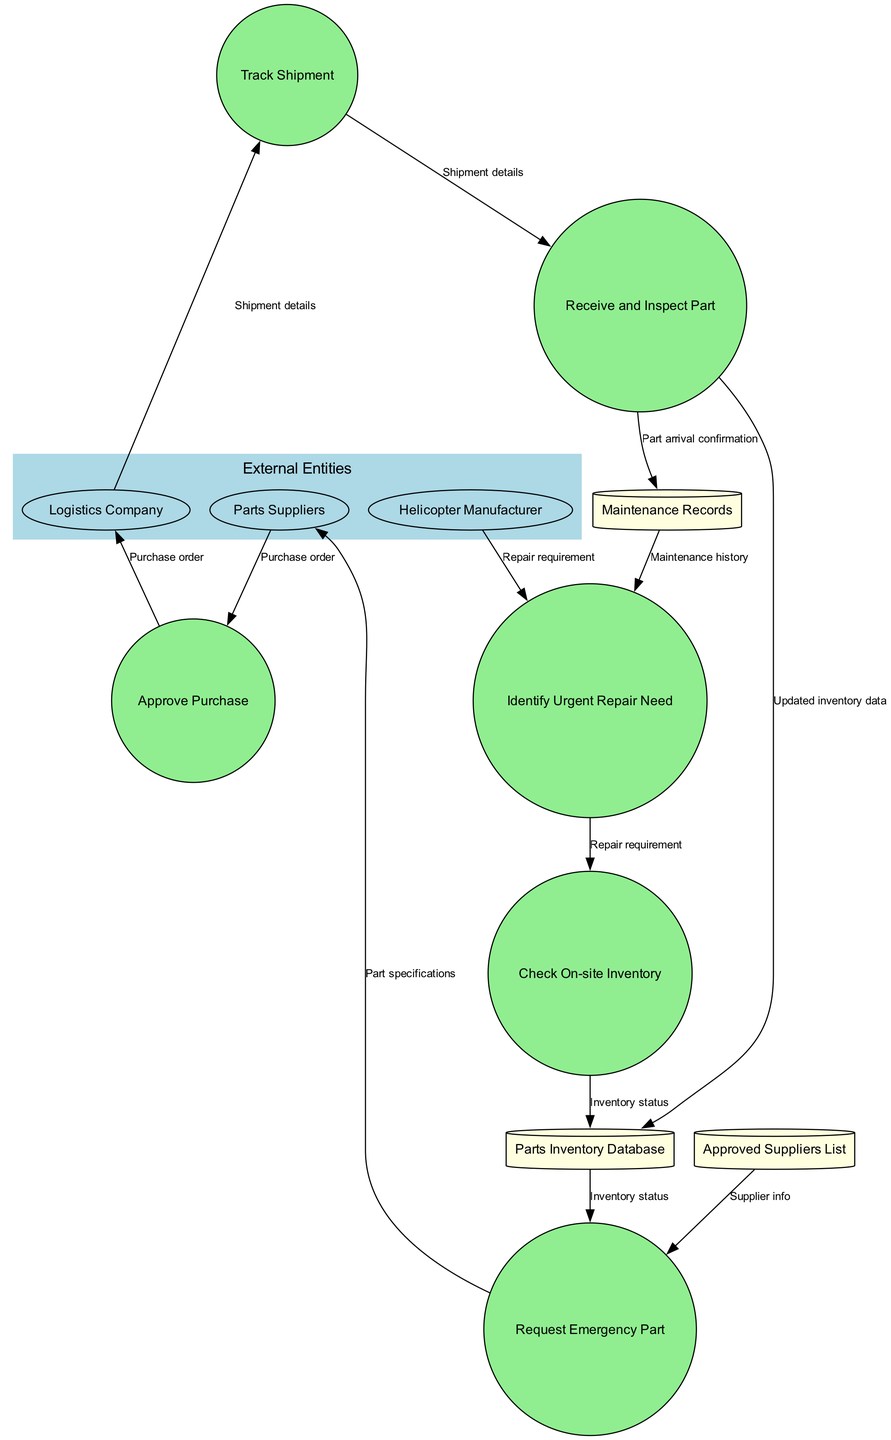What's the number of external entities present in the diagram? The diagram indicates three external entities: Helicopter Manufacturer, Parts Suppliers, and Logistics Company. Therefore, the total count is three.
Answer: 3 What is the first process in the emergency parts procurement process? The first process is "Identify Urgent Repair Need," as it is the initial action depicted in the diagram before any inventory check or request for parts.
Answer: Identify Urgent Repair Need Which data store is used to track parts availability on-site? The "Parts Inventory Database" is specifically designed to keep track of parts available on-site, evidenced by the connection from the "Check On-site Inventory" process to this data store.
Answer: Parts Inventory Database What must occur after the "Request Emergency Part" process? After "Request Emergency Part," the process must go to "Approve Purchase," as the purchase approval is essential before proceeding with the suppliers.
Answer: Approve Purchase How many processes flow from the "Logistics Company"? There is one process flowing from the "Logistics Company," which is "Track Shipment," connecting the logistics operations to the tracking of the shipments.
Answer: 1 What data flow connects "Parts Suppliers" to the "Approve Purchase" process? The data flow that connects "Parts Suppliers" to the "Approve Purchase" process is the "Purchase order," which represents essential details for purchasing parts.
Answer: Purchase order What are the two main functions of the "Receive and Inspect Part" process? The "Receive and Inspect Part" process performs two primary functions: receiving the part and inspecting it to ensure it meets the required specifications before being added to inventory.
Answer: Receive and Inspect Part In the data flow between "Check On-site Inventory" and the "Parts Inventory Database," what type of information is exchanged? The information exchanged is "Inventory status," as the process checks the current inventory level and updates it via this data flow.
Answer: Inventory status Which external entity is responsible for being informed about the repair requirement? The "Helicopter Manufacturer" is responsible for being informed about the repair requirement, as it connects in the data flow to the "Identify Urgent Repair Need" process.
Answer: Helicopter Manufacturer What is the final output of the emergency parts procurement process? The final output is "Updated inventory data," reflecting the receipt and inspection of the emergency part and its addition to the inventory.
Answer: Updated inventory data 